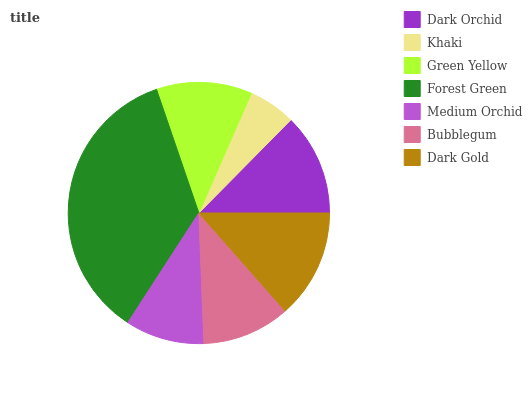Is Khaki the minimum?
Answer yes or no. Yes. Is Forest Green the maximum?
Answer yes or no. Yes. Is Green Yellow the minimum?
Answer yes or no. No. Is Green Yellow the maximum?
Answer yes or no. No. Is Green Yellow greater than Khaki?
Answer yes or no. Yes. Is Khaki less than Green Yellow?
Answer yes or no. Yes. Is Khaki greater than Green Yellow?
Answer yes or no. No. Is Green Yellow less than Khaki?
Answer yes or no. No. Is Green Yellow the high median?
Answer yes or no. Yes. Is Green Yellow the low median?
Answer yes or no. Yes. Is Dark Orchid the high median?
Answer yes or no. No. Is Dark Gold the low median?
Answer yes or no. No. 